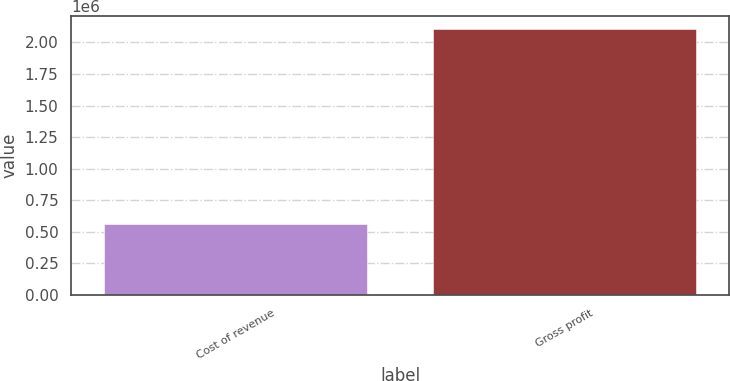Convert chart to OTSL. <chart><loc_0><loc_0><loc_500><loc_500><bar_chart><fcel>Cost of revenue<fcel>Gross profit<nl><fcel>562401<fcel>2.10293e+06<nl></chart> 